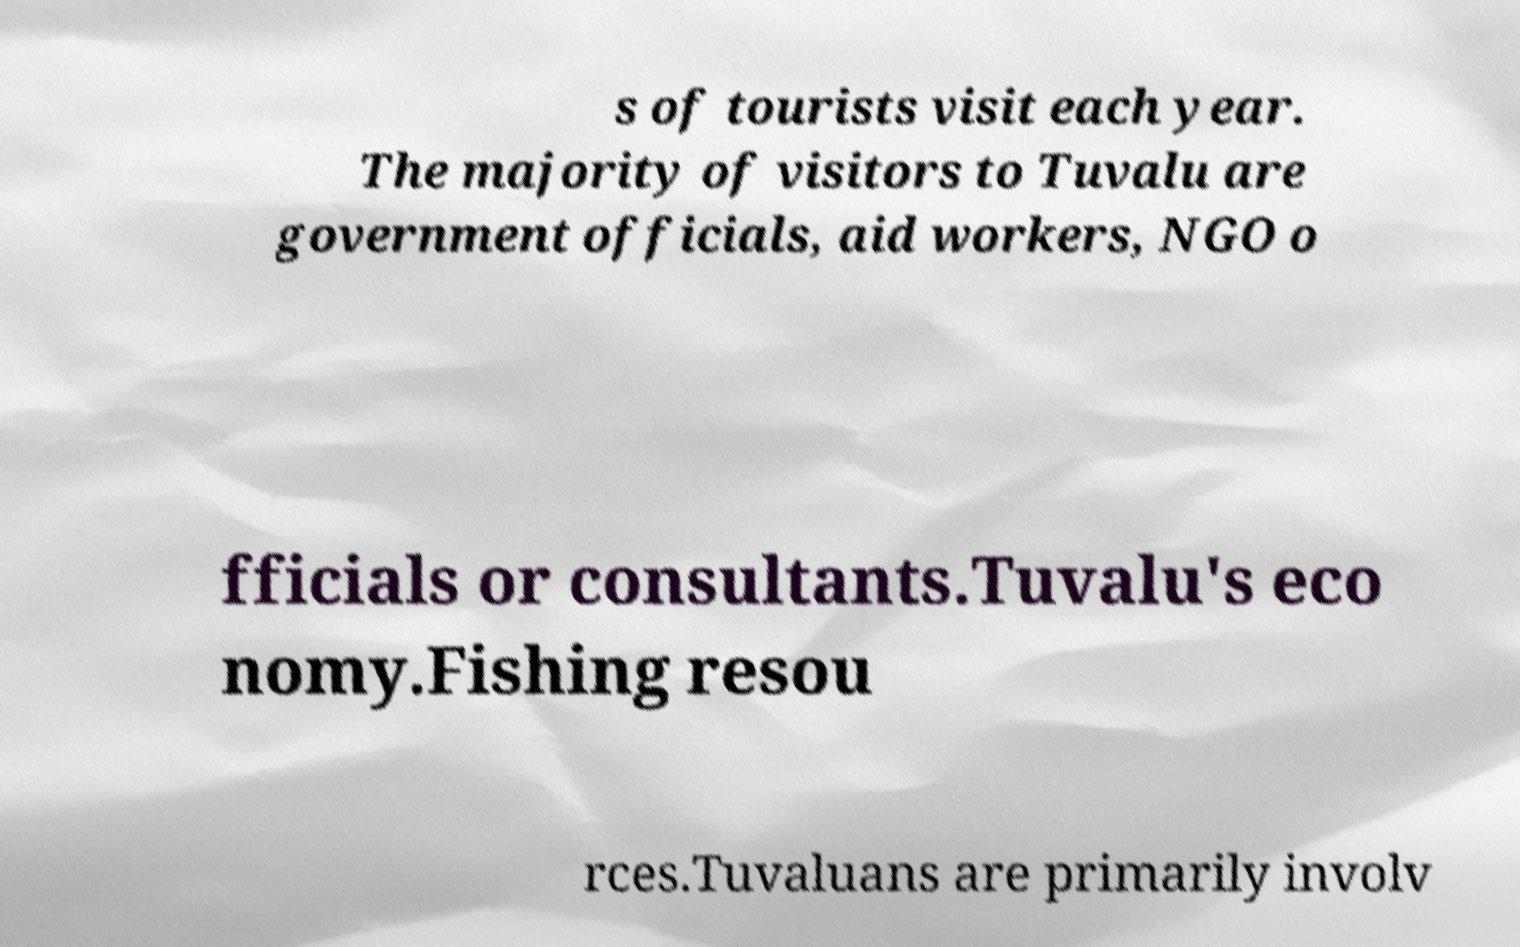What messages or text are displayed in this image? I need them in a readable, typed format. s of tourists visit each year. The majority of visitors to Tuvalu are government officials, aid workers, NGO o fficials or consultants.Tuvalu's eco nomy.Fishing resou rces.Tuvaluans are primarily involv 